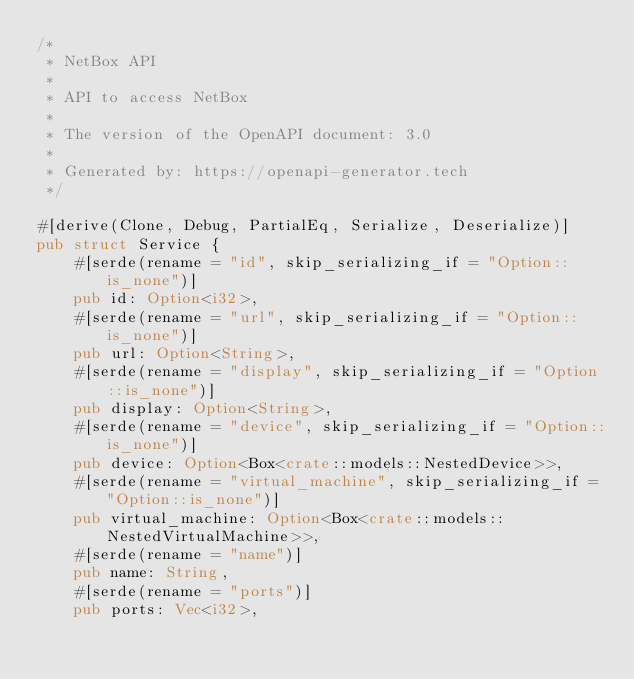Convert code to text. <code><loc_0><loc_0><loc_500><loc_500><_Rust_>/*
 * NetBox API
 *
 * API to access NetBox
 *
 * The version of the OpenAPI document: 3.0
 *
 * Generated by: https://openapi-generator.tech
 */

#[derive(Clone, Debug, PartialEq, Serialize, Deserialize)]
pub struct Service {
    #[serde(rename = "id", skip_serializing_if = "Option::is_none")]
    pub id: Option<i32>,
    #[serde(rename = "url", skip_serializing_if = "Option::is_none")]
    pub url: Option<String>,
    #[serde(rename = "display", skip_serializing_if = "Option::is_none")]
    pub display: Option<String>,
    #[serde(rename = "device", skip_serializing_if = "Option::is_none")]
    pub device: Option<Box<crate::models::NestedDevice>>,
    #[serde(rename = "virtual_machine", skip_serializing_if = "Option::is_none")]
    pub virtual_machine: Option<Box<crate::models::NestedVirtualMachine>>,
    #[serde(rename = "name")]
    pub name: String,
    #[serde(rename = "ports")]
    pub ports: Vec<i32>,</code> 